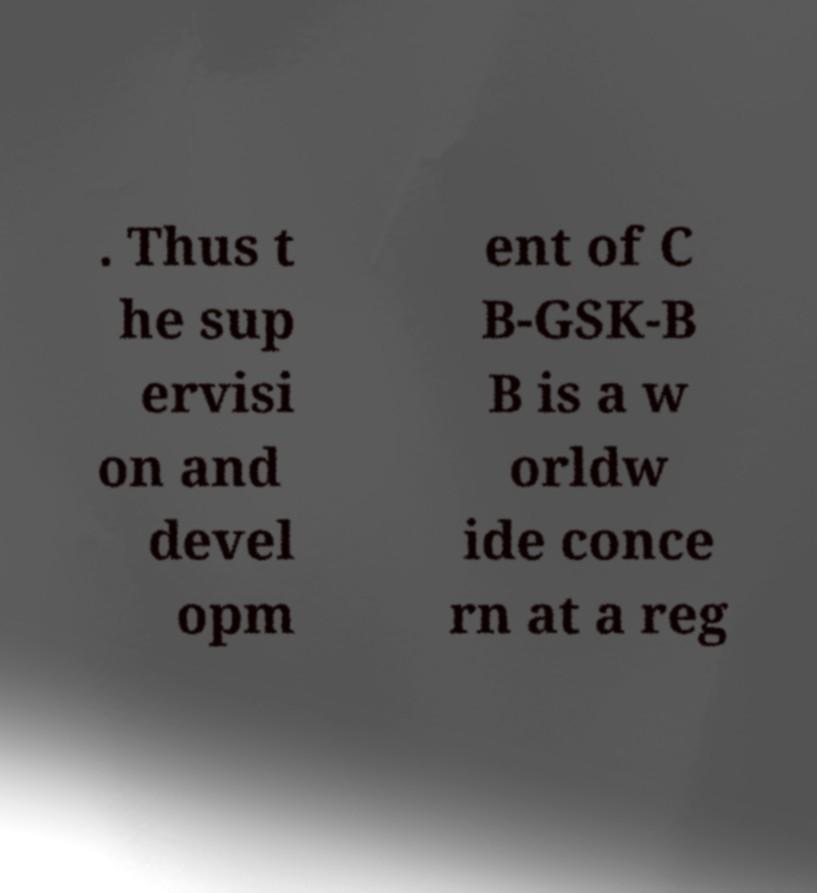Can you read and provide the text displayed in the image?This photo seems to have some interesting text. Can you extract and type it out for me? . Thus t he sup ervisi on and devel opm ent of C B-GSK-B B is a w orldw ide conce rn at a reg 